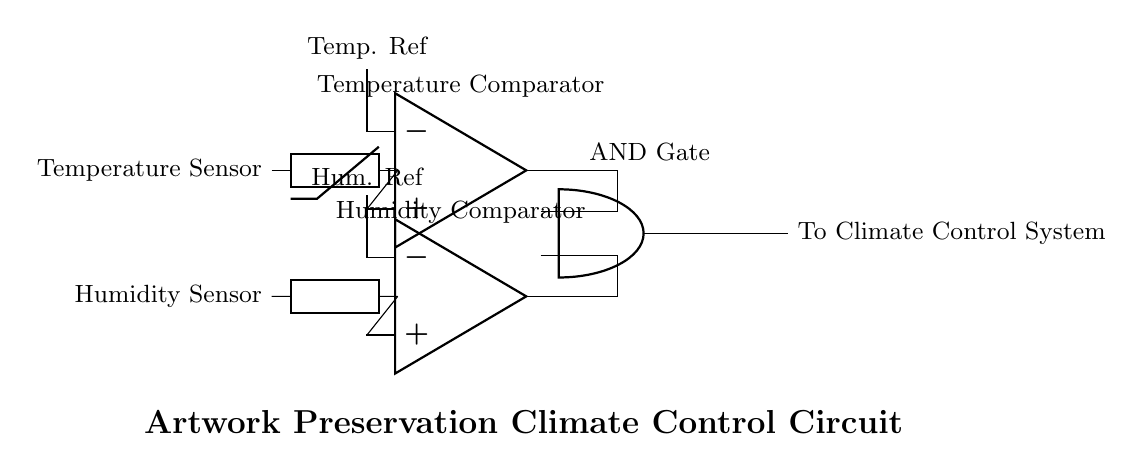What types of sensors are used in this circuit? The circuit includes a temperature sensor and a humidity sensor. These sensors provide the necessary data to compare against reference values for regulation.
Answer: Temperature and humidity What outputs do the comparators produce? The comparators produce signals based on the comparison between input values from the sensors and their reference levels. If conditions are met (for example, temperature and humidity within defined ranges), they output a signal to the AND gate.
Answer: Signals What is the purpose of the AND gate in this circuit? The AND gate combines the outputs of the temperature and humidity comparators. It will only send a signal to activate the climate control system if both conditions (optimal temperature and humidity) are met.
Answer: To combine signals How many comparators are there in the circuit? The circuit diagram shows two comparators, one for temperature and one for humidity. This facilitates independent yet simultaneous evaluations of both environmental factors.
Answer: Two What happens if either the temperature or humidity is outside the optimal range? If either the temperature or humidity is outside its optimal range, the corresponding comparator will not send a signal to the AND gate. Consequently, the AND gate will not activate the climate control system, preventing unnecessary climate adjustments.
Answer: No activation Which components provide inputs to the AND gate? The inputs to the AND gate come from the outputs of the temperature comparator and the humidity comparator. These inputs determine the overall state of the climate control system.
Answer: Temperature and humidity comparators 